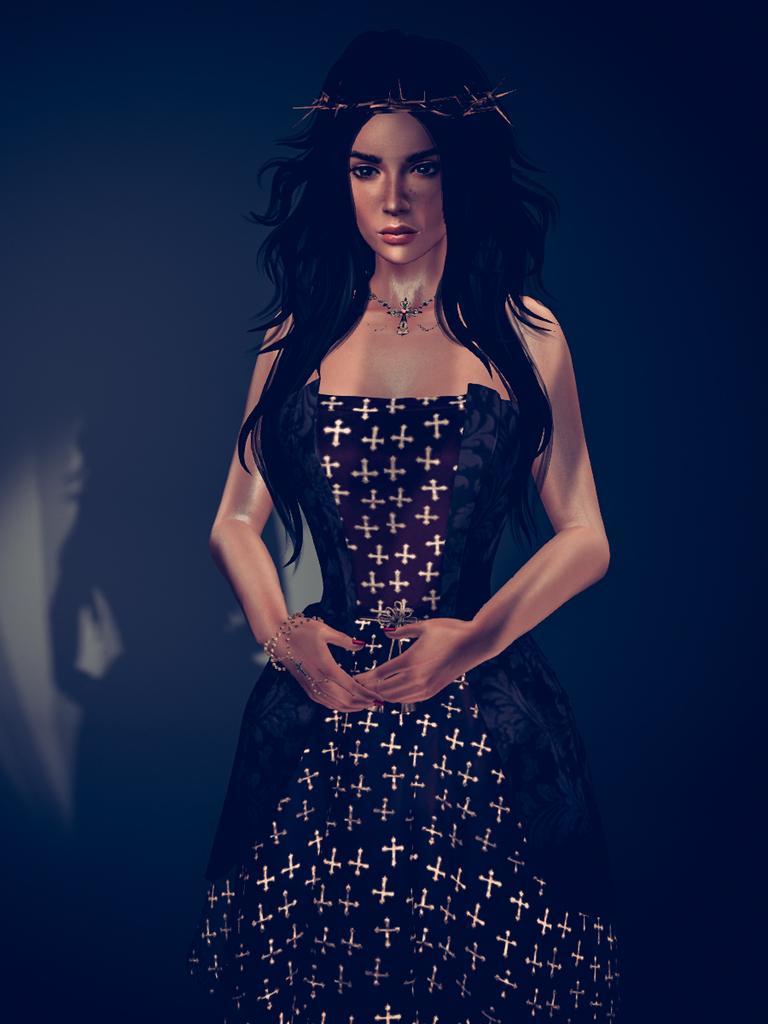Describe this image in one or two sentences. This image is a cartoon. In this image we can see a woman. 